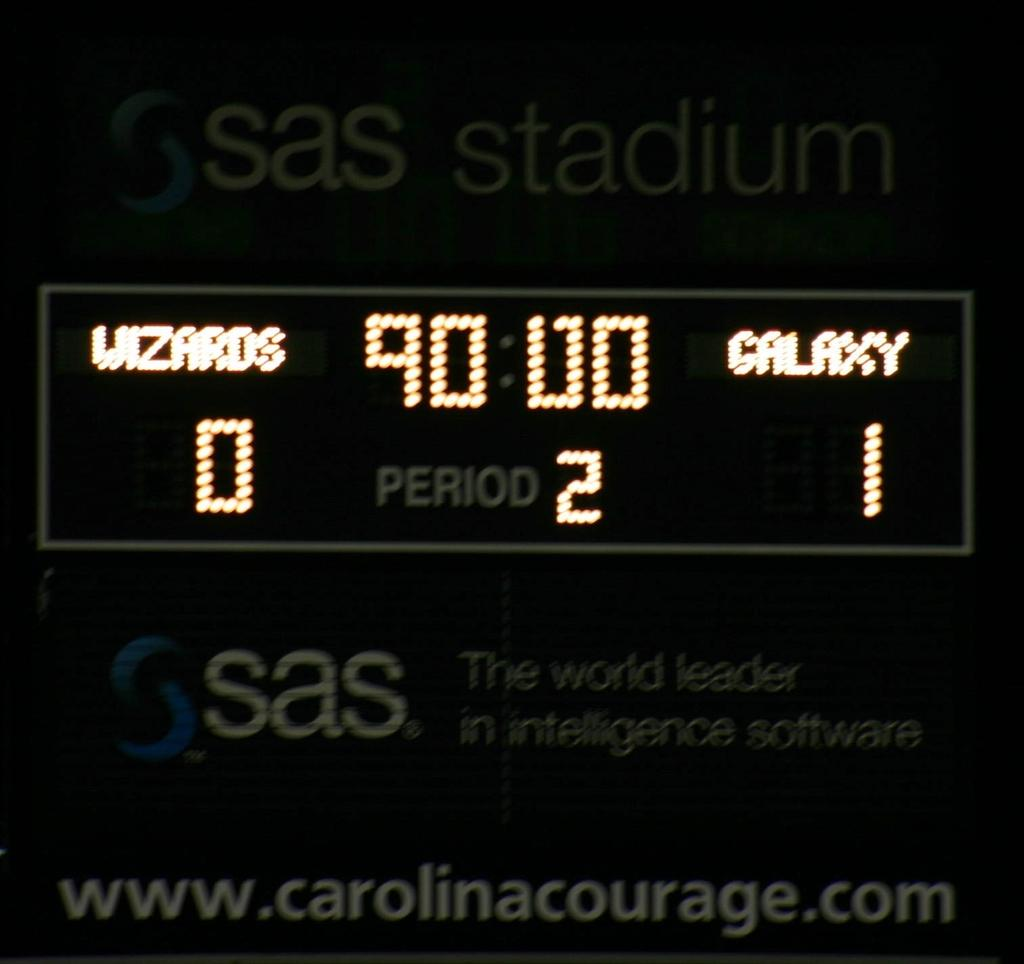<image>
Write a terse but informative summary of the picture. A digital scoreboard at sas stadium with time clock at 90:00. 